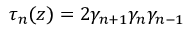Convert formula to latex. <formula><loc_0><loc_0><loc_500><loc_500>\tau _ { n } ( z ) = 2 \gamma _ { n + 1 } \gamma _ { n } \gamma _ { n - 1 }</formula> 